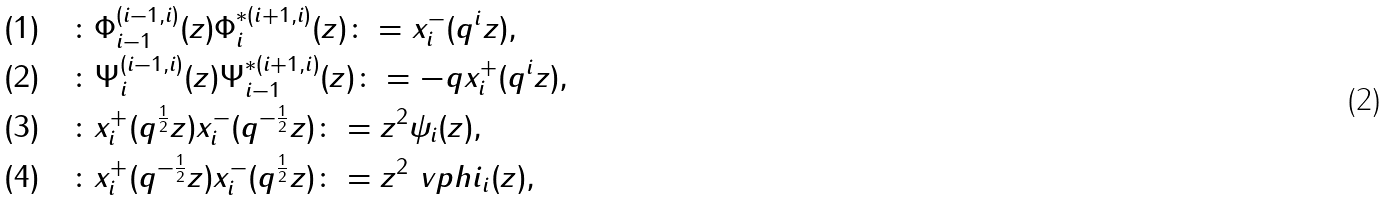<formula> <loc_0><loc_0><loc_500><loc_500>\text {$(1)$} & \quad \colon \Phi _ { i - 1 } ^ { ( i - 1 , i ) } ( z ) \Phi _ { i } ^ { \ast ( i + 1 , i ) } ( z ) \colon = x _ { i } ^ { - } ( q ^ { i } z ) , \\ \text {$(2)$} & \quad \colon \Psi _ { i } ^ { ( i - 1 , i ) } ( z ) \Psi _ { i - 1 } ^ { \ast ( i + 1 , i ) } ( z ) \colon = - q x _ { i } ^ { + } ( q ^ { i } z ) , \\ \text {$(3)$} & \quad \colon x _ { i } ^ { + } ( q ^ { \frac { 1 } { 2 } } z ) x _ { i } ^ { - } ( q ^ { - \frac { 1 } { 2 } } z ) \colon = z ^ { 2 } \psi _ { i } ( z ) , \\ \text {$(4)$} & \quad \colon x _ { i } ^ { + } ( q ^ { - \frac { 1 } { 2 } } z ) x _ { i } ^ { - } ( q ^ { \frac { 1 } { 2 } } z ) \colon = z ^ { 2 } \ v p h i _ { i } ( z ) ,</formula> 